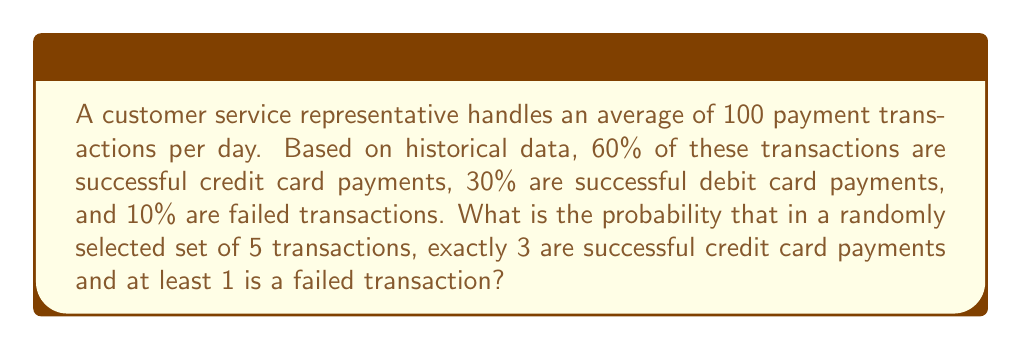Give your solution to this math problem. Let's approach this step-by-step using the concepts of probability and combinations:

1) First, we need to calculate the probability of each outcome:
   P(credit card success) = 0.60
   P(debit card success) = 0.30
   P(failed transaction) = 0.10

2) We want exactly 3 credit card successes out of 5 transactions. This follows a binomial distribution:

   $${5 \choose 3} (0.60)^3 (0.40)^2 = 10 \cdot 0.216 \cdot 0.16 = 0.3456$$

3) Now, for the remaining 2 transactions, we need at least 1 failed transaction. This can happen in two ways:
   a) 1 failed and 1 debit success
   b) 2 failed

4) Probability of 1 failed and 1 debit success:
   $$2 \cdot 0.10 \cdot 0.30 = 0.06$$

5) Probability of 2 failed:
   $$(0.10)^2 = 0.01$$

6) Total probability of at least 1 failed in 2 transactions:
   $$0.06 + 0.01 = 0.07$$

7) The final probability is the product of the probability of 3 credit card successes and the probability of at least 1 failed transaction in the remaining 2:

   $$0.3456 \cdot 0.07 = 0.024192$$
Answer: 0.024192 